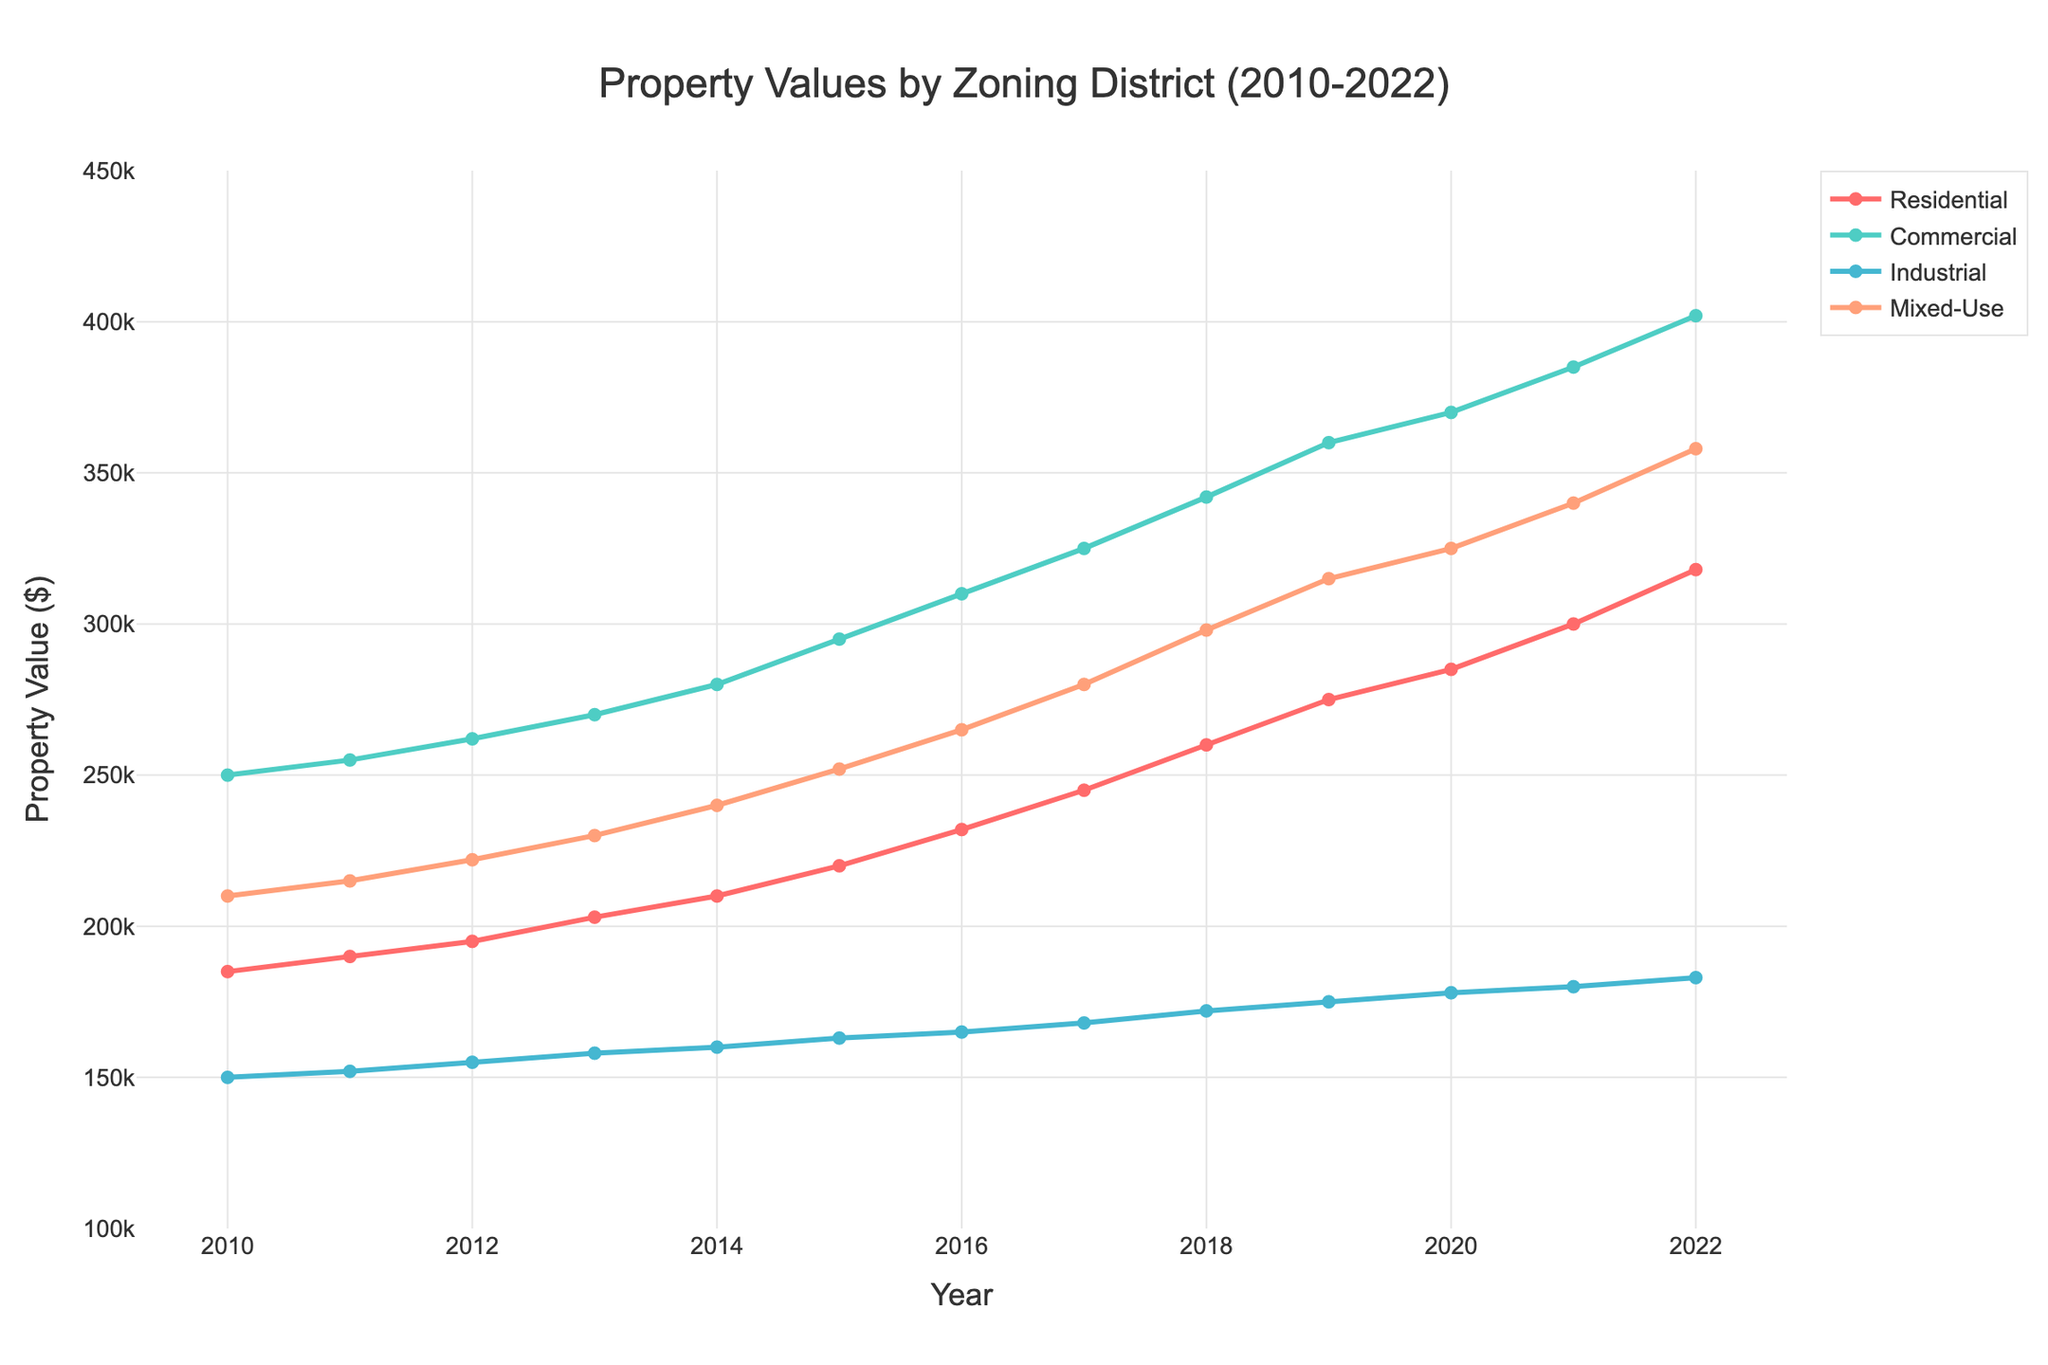What was the property value for Residential zoning in 2014? Look for the data point on the line for Residential zoning at the year 2014.
Answer: $210,000 Which zoning district had the highest property value in 2019? Compare the data points for all zoning districts at the year 2019. Commercial zoning had the highest value among them.
Answer: Commercial In which year did the property value for Mixed-Use zoning reach $300,000? Find the data point where the line for Mixed-Use zoning crosses or reaches $300,000. This occurs in 2018.
Answer: 2018 Did the property values in the Industrial zoning district ever surpass those in the Residential zoning district during the given time period? Compare the plot lines for Residential and Industrial zoning districts across all years. The Industrial property values always remained lower than Residential.
Answer: No What's the average property value of Residential zoning from 2010 to 2015? Sum the values for Residential from 2010 to 2015 and divide by 6 (years). Average = (185000 + 190000 + 195000 + 203000 + 210000 + 220000) / 6 = 200500.
Answer: $200,500 By how much did Commercial zoning property values increase from 2010 to 2022? Subtract the Commercial value in 2010 from the value in 2022. Increase = 402000 - 250000 = 152000.
Answer: $152,000 In 2021, which zoning district had the second-highest property value? Compare the property values for all zoning districts in 2021; Mixed-Use had the highest, followed by Commercial.
Answer: Commercial How does the growth rate of Residential zoning property values compare to that of Industrial zoning from 2010 to 2022? Calculate the overall increase for each, then compare. Residential: 318000 - 185000 = 133000; Industrial: 183000 - 150000 = 33000. Residential grew more rapidly.
Answer: Residential grew faster Which color represents the Mixed-Use zoning and how did its property value trend from 2010 to 2022? Identify the color used for Mixed-Use (orange) and observe the trend line, which steadily increased.
Answer: Orange, steadily increased What's the total increase in property value for Mixed-Use zoning between 2010 and 2015? Subtract the Mixed-Use value in 2010 from the value in 2015. Increase = 252000 - 210000 = 42000.
Answer: $42,000 